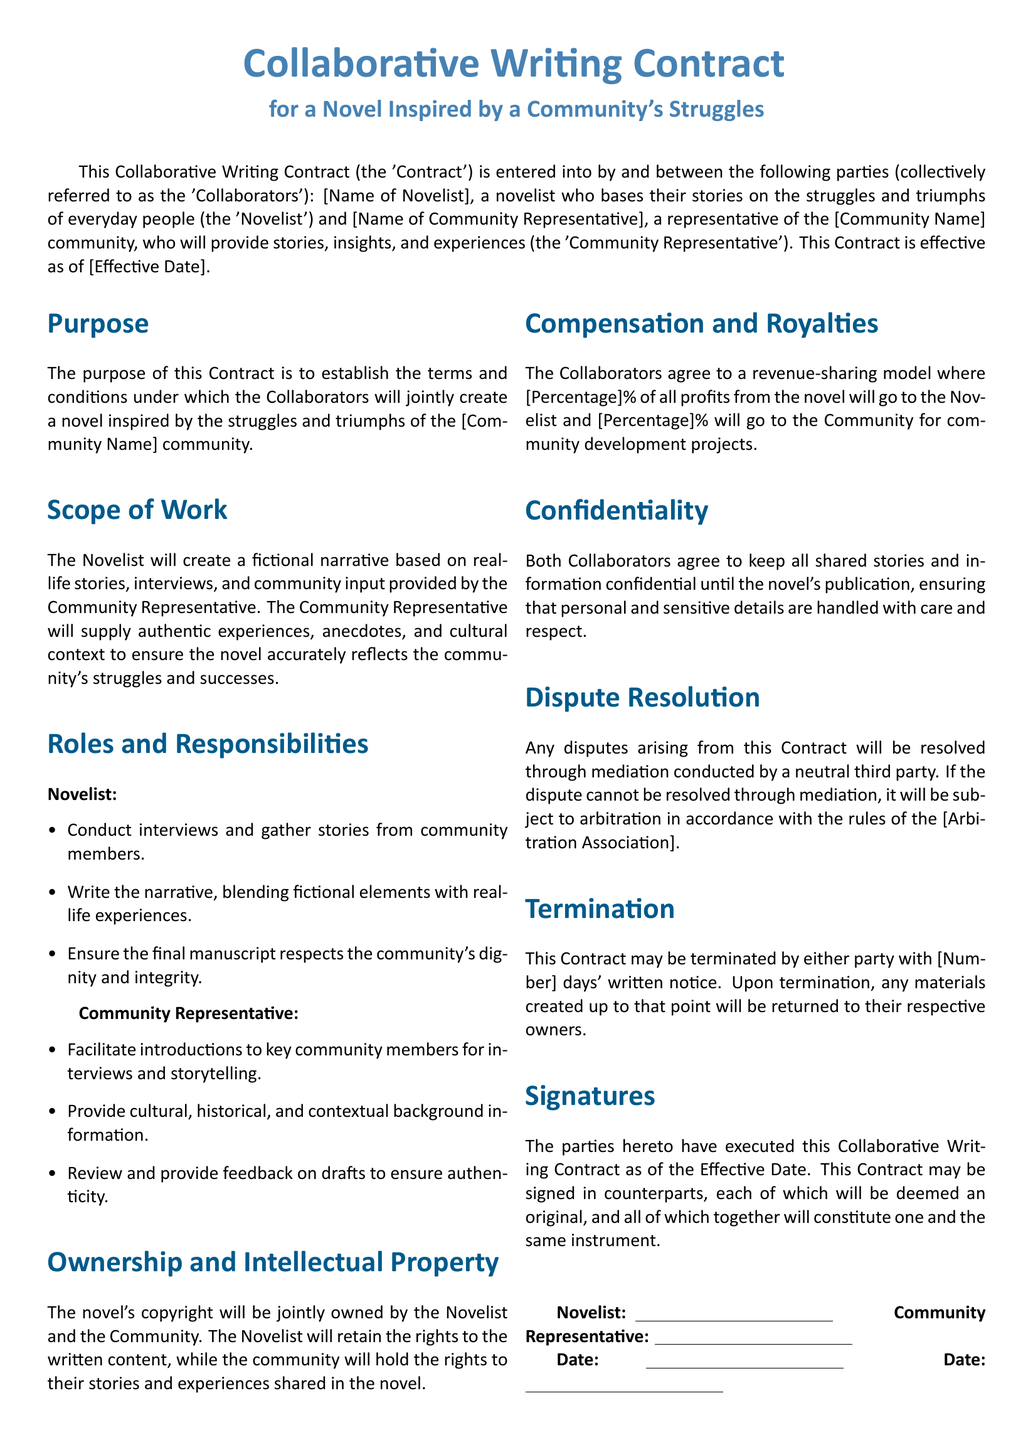What is the title of the document? The title of the document is specified at the beginning of the Contract.
Answer: Collaborative Writing Contract Who are the parties involved in this Contract? The parties involved are identified in the document as the Novelist and the Community Representative.
Answer: Novelist and Community Representative What is the purpose of this Contract? The purpose is provided in the document, detailing the intention behind the Contract.
Answer: Establish the terms What responsibilities does the Novelist have? The responsibilities of the Novelist are listed clearly in the Contract, indicating their specific duties.
Answer: Conduct interviews and gather stories What percentage of profits does the Community receive? The document specifies a percentage allocation for the Community in the revenue-sharing model.
Answer: [Percentage]% What does the confidentiality clause entail? The confidentiality clause outlines agreements regarding the handling of shared stories and information.
Answer: Keep all shared stories confidential How can the Contract be terminated? The termination process is described, including notice required from either party.
Answer: [Number] days' written notice What happens in case of a dispute? The document outlines a procedure for dispute resolution, including mediation and arbitration.
Answer: Mediation conducted by a neutral third party What is the effective date of the Contract? The effective date is stated later in the document where it's filled out.
Answer: [Effective Date] 